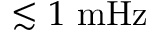<formula> <loc_0><loc_0><loc_500><loc_500>\lesssim 1 m H z</formula> 